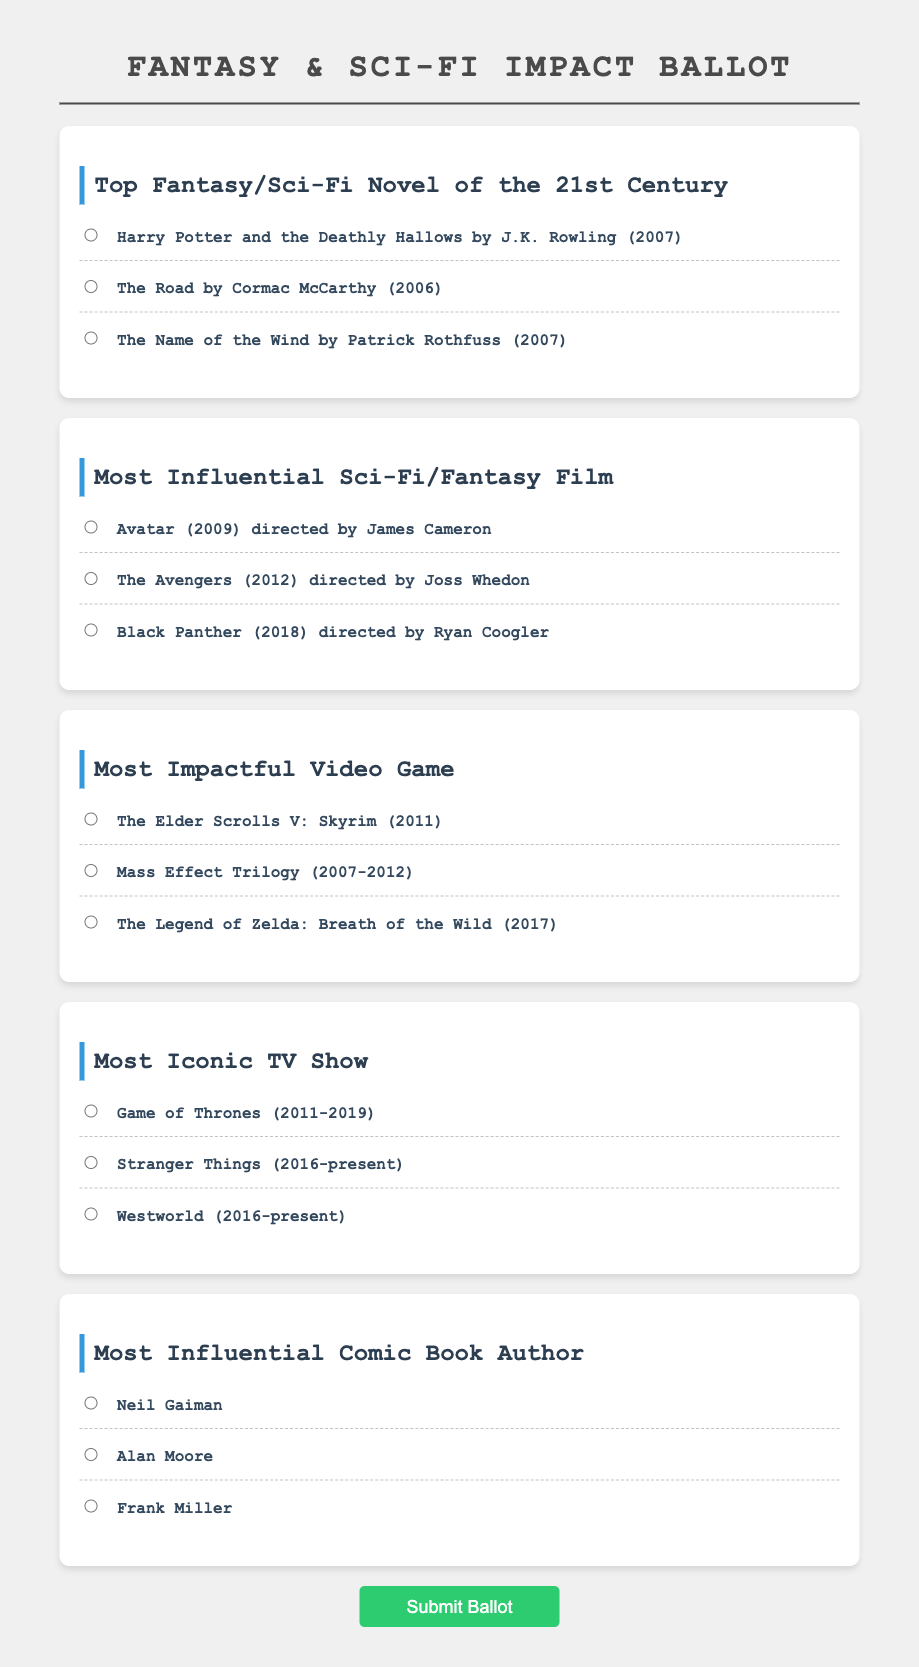What is the title of the most popular fantasy novel of the 21st century according to the ballot? The ballot lists "Harry Potter and the Deathly Hallows" as one of the choices for the top fantasy novel.
Answer: Harry Potter and the Deathly Hallows Who directed the film "Black Panther"? The ballot specifies that "Black Panther" was directed by Ryan Coogler.
Answer: Ryan Coogler How many impactful video games are listed in the ballot? The ballot presents three options for the most impactful video game.
Answer: 3 What is the name of the TV show that aired from 2011 to 2019? The ballot includes "Game of Thrones" as an option, which fits this description.
Answer: Game of Thrones Which comic book author is listed first in the ballot? In the ballot, "Neil Gaiman" is the first author mentioned under influential comic book authors.
Answer: Neil Gaiman Which genre does "The Name of the Wind" belong to? The ballot categorizes "The Name of the Wind," indicating it is a fantasy novel.
Answer: Fantasy What year was "Avatar" released? The ballot notes that "Avatar" was released in 2009.
Answer: 2009 What is the last item listed under the impactful video game section? The ballot specifies "The Legend of Zelda: Breath of the Wild" as the last option under impactful video games.
Answer: The Legend of Zelda: Breath of the Wild How many authors are mentioned in the comic book section? The ballot presents three authors as options, indicating there are three authors listed.
Answer: 3 